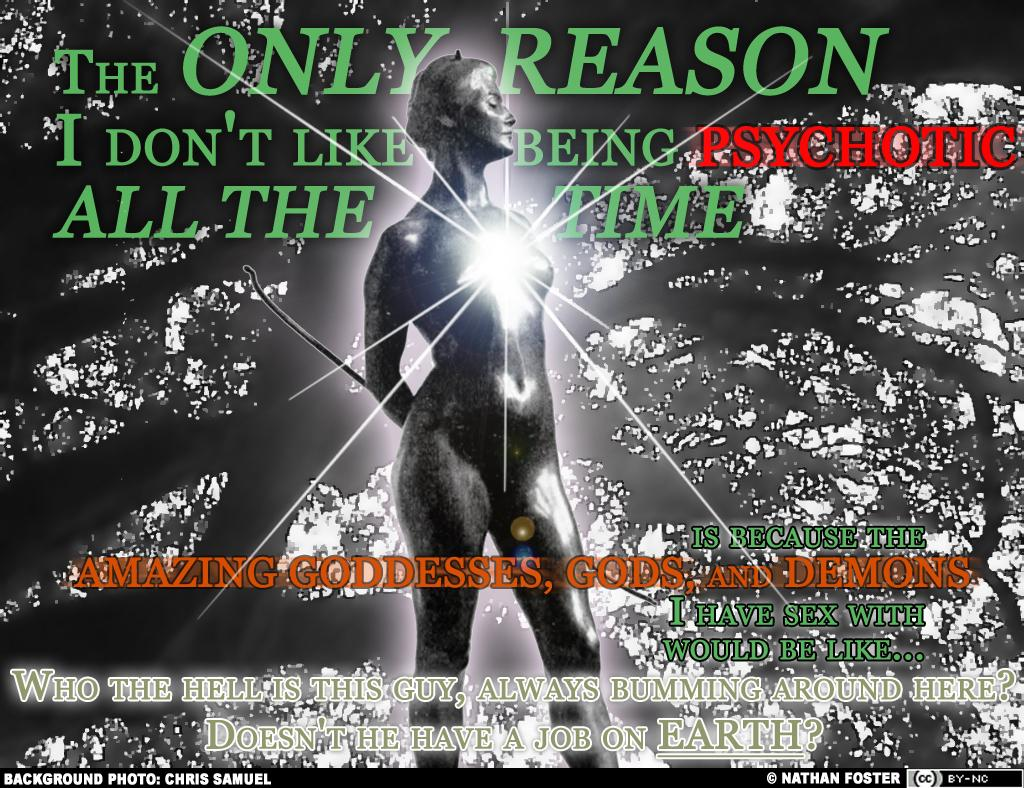What is the color of the poster in the image? The poster in the image is black. What type of natural element can be seen in the image? There is a big tree visible in the image. What is the statue in the image representing? The specific representation of the statue cannot be determined from the provided facts. What is written on the poster? There is text on the poster. What advice is the statue giving to the tree in the image? There is no indication in the image that the statue is giving advice to the tree, as statues are inanimate objects and cannot provide advice. 